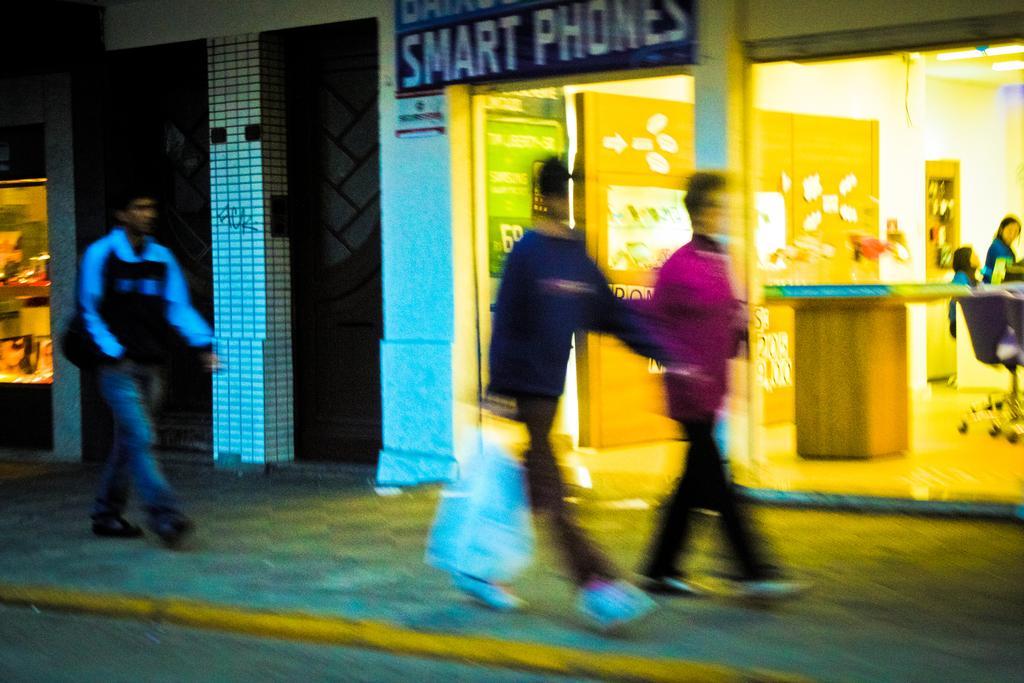Could you give a brief overview of what you see in this image? In front of the picture, we see three men are walking on the footpath. Beside that, we see the buildings and the glass door from which we can see the table, wall and a board on which many posters or stickers are pasted. Beside that, we see a board in green color with some text written on it. On the right side, we see two women are standing. At the top, we see the board in blue color with some text written on it. On the left side, we see a building and it looks like a shop. This picture is blurred. 